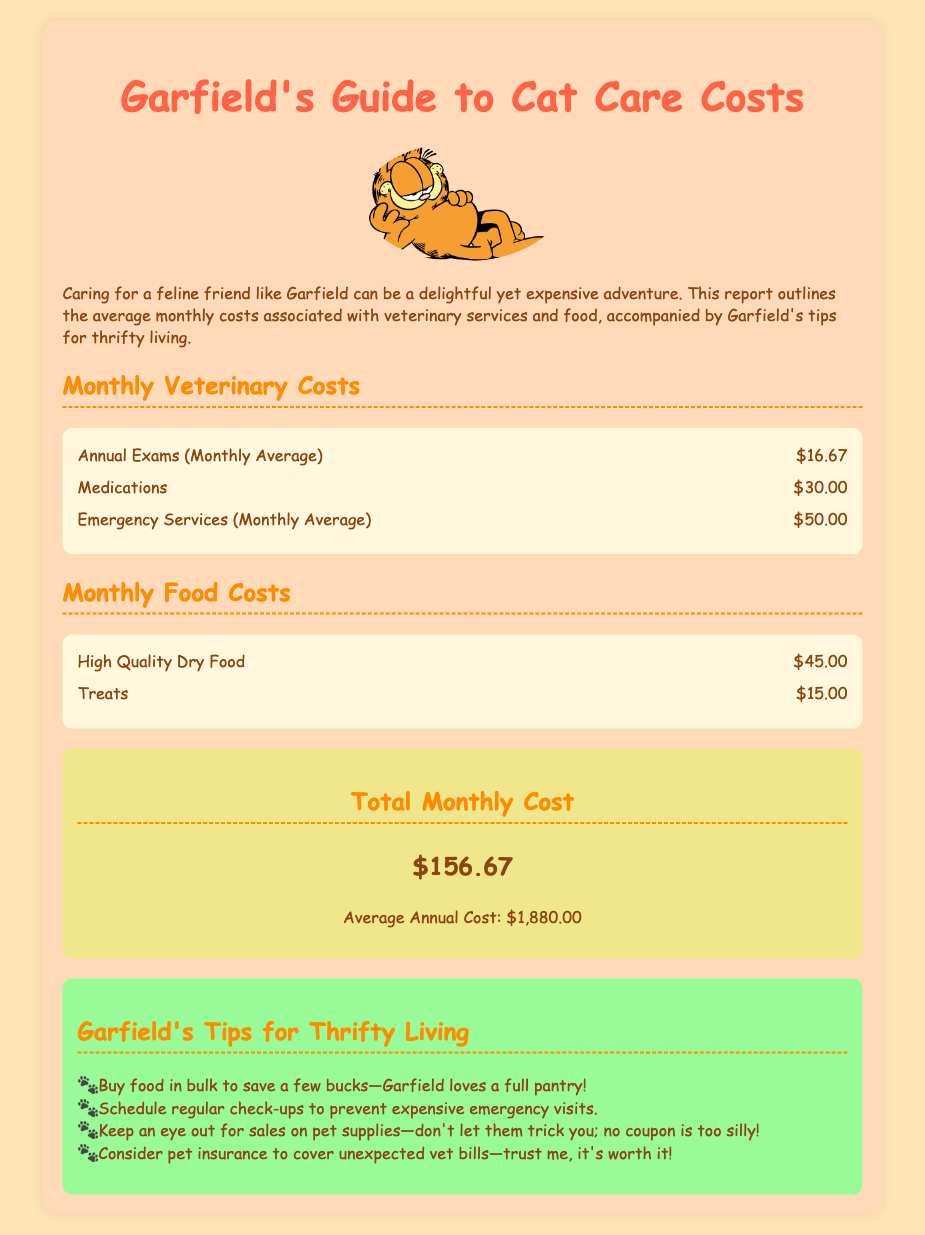what is the average monthly cost for medications? The document states that the average monthly cost for medications is $30.00.
Answer: $30.00 what is the total monthly cost? The total monthly cost is provided as a summary in the document, which is $156.67.
Answer: $156.67 how much does Garfield suggest to save by buying food in bulk? The document implies that buying food in bulk saves "a few bucks," a phrase indicating some savings but not a specific amount.
Answer: a few bucks what is the average annual cost of cat care? The report mentions the average annual cost as $1,880.00.
Answer: $1,880.00 how much do treats cost monthly? The cost of treats is directly listed in the food costs section, which is $15.00.
Answer: $15.00 what are the two categories of costs outlined in the document? The categories are veterinary costs and food costs, as these are the main sections of the document.
Answer: veterinary costs and food costs why is it recommended to schedule regular check-ups? The document mentions scheduling regular check-ups prevents expensive emergency visits, indicating a reasoning for the recommendation.
Answer: prevent expensive emergency visits what type of image is included in the document? The image included is of Garfield the Cat, as referenced in the visual content description.
Answer: Garfield the Cat 